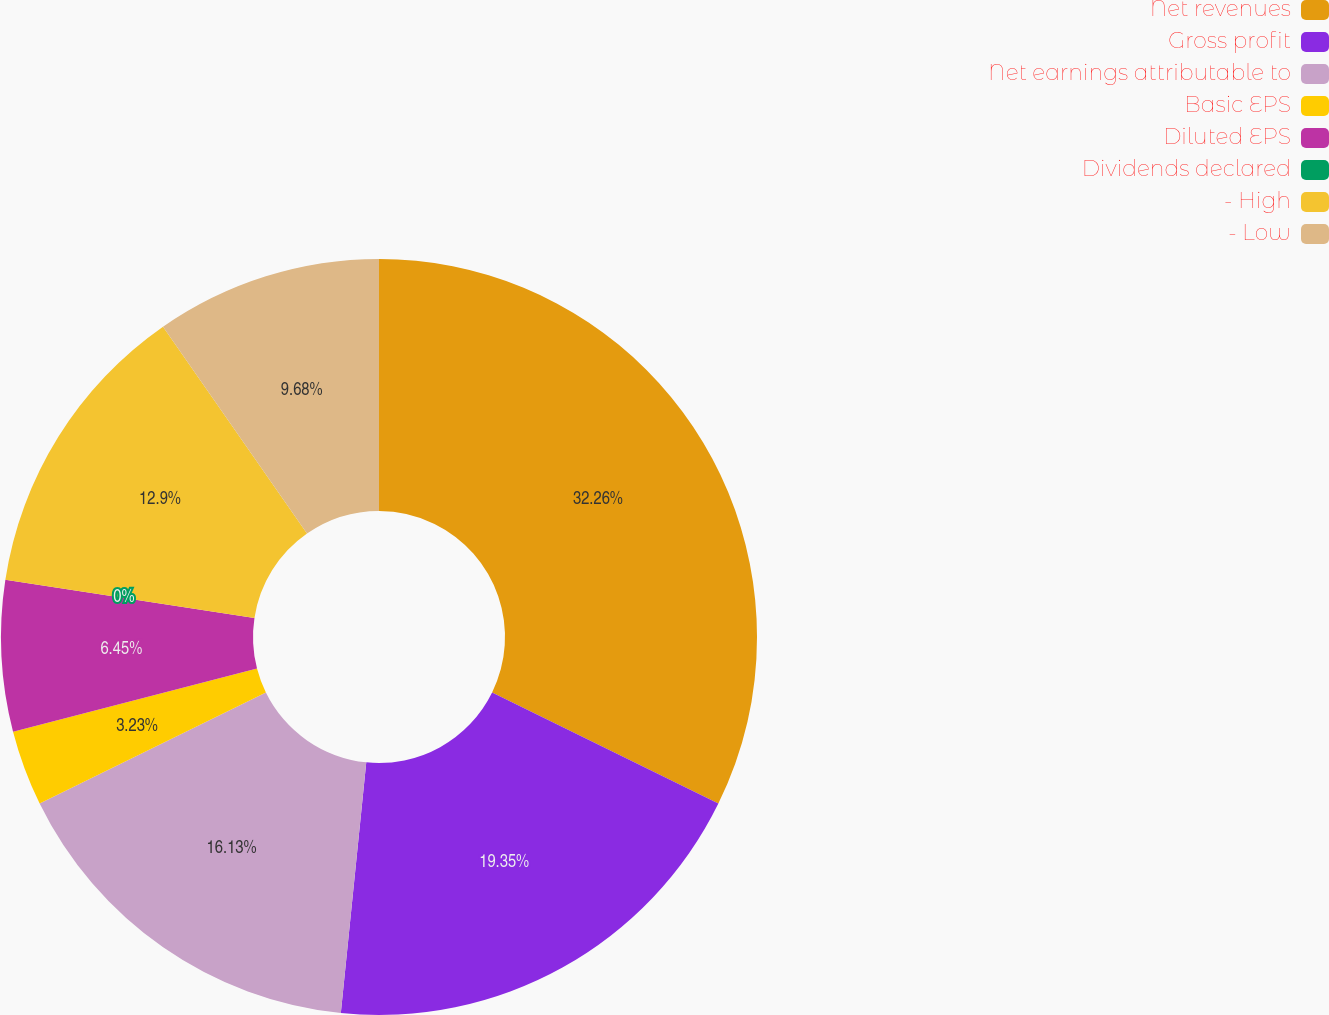Convert chart. <chart><loc_0><loc_0><loc_500><loc_500><pie_chart><fcel>Net revenues<fcel>Gross profit<fcel>Net earnings attributable to<fcel>Basic EPS<fcel>Diluted EPS<fcel>Dividends declared<fcel>- High<fcel>- Low<nl><fcel>32.26%<fcel>19.35%<fcel>16.13%<fcel>3.23%<fcel>6.45%<fcel>0.0%<fcel>12.9%<fcel>9.68%<nl></chart> 